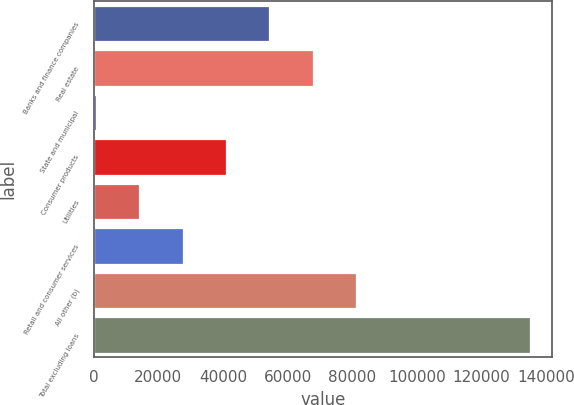<chart> <loc_0><loc_0><loc_500><loc_500><bar_chart><fcel>Banks and finance companies<fcel>Real estate<fcel>State and municipal<fcel>Consumer products<fcel>Utilities<fcel>Retail and consumer services<fcel>All other (b)<fcel>Total excluding loans<nl><fcel>54347.8<fcel>67787<fcel>591<fcel>40908.6<fcel>14030.2<fcel>27469.4<fcel>81226.2<fcel>134983<nl></chart> 